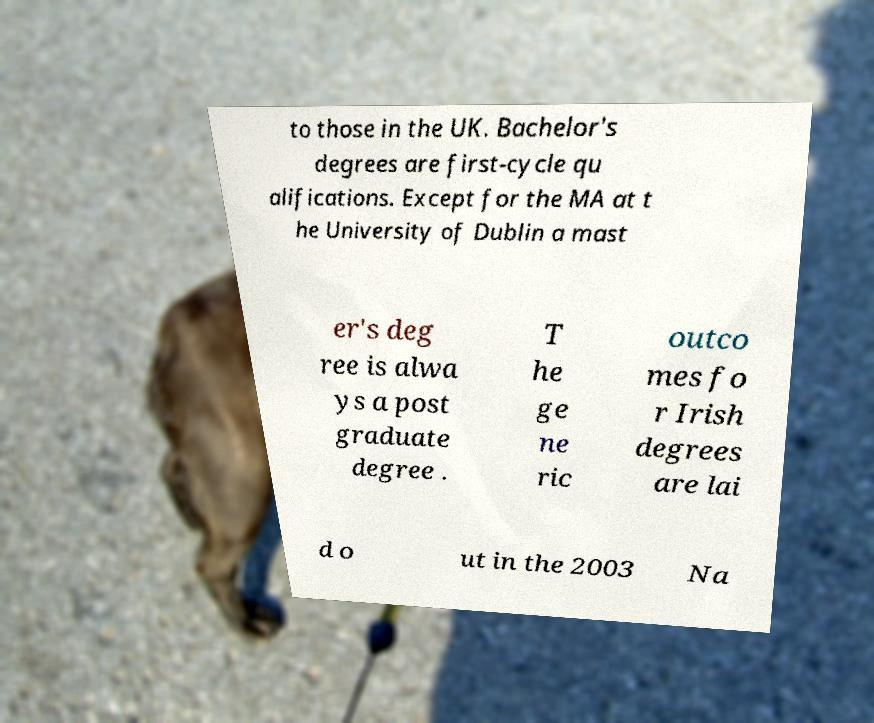There's text embedded in this image that I need extracted. Can you transcribe it verbatim? to those in the UK. Bachelor's degrees are first-cycle qu alifications. Except for the MA at t he University of Dublin a mast er's deg ree is alwa ys a post graduate degree . T he ge ne ric outco mes fo r Irish degrees are lai d o ut in the 2003 Na 